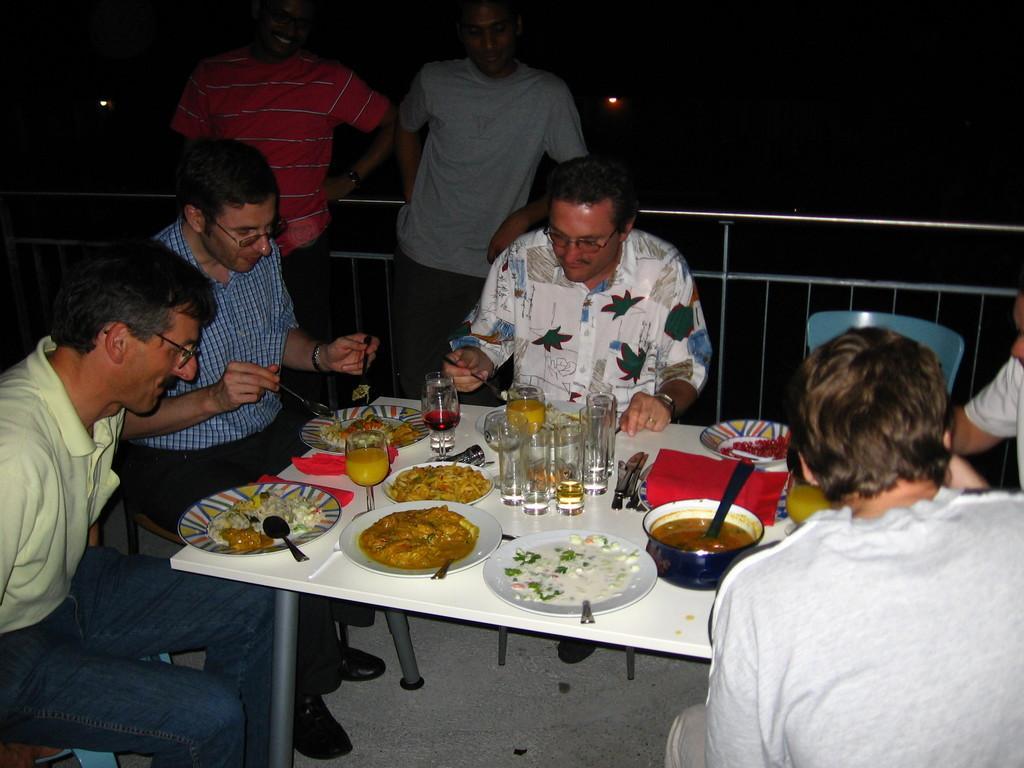In one or two sentences, can you explain what this image depicts? As we can see in the image there is are two people standing and five people sitting on chairs and there is a table over here. On table there are plates, glasses and spoons. 